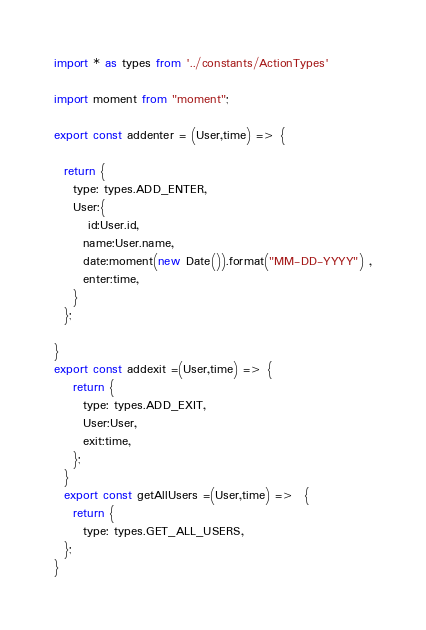Convert code to text. <code><loc_0><loc_0><loc_500><loc_500><_JavaScript_>import * as types from '../constants/ActionTypes'

import moment from "moment";

export const addenter = (User,time) => {
 
  return { 
    type: types.ADD_ENTER,
    User:{
       id:User.id,
      name:User.name,
      date:moment(new Date()).format("MM-DD-YYYY") ,
      enter:time,
    }
  };
 
}
export const addexit =(User,time) => {
    return {
      type: types.ADD_EXIT,
      User:User,
      exit:time,
    };
  }
  export const getAllUsers =(User,time) =>  {
    return {    
      type: types.GET_ALL_USERS,
  };
}
</code> 